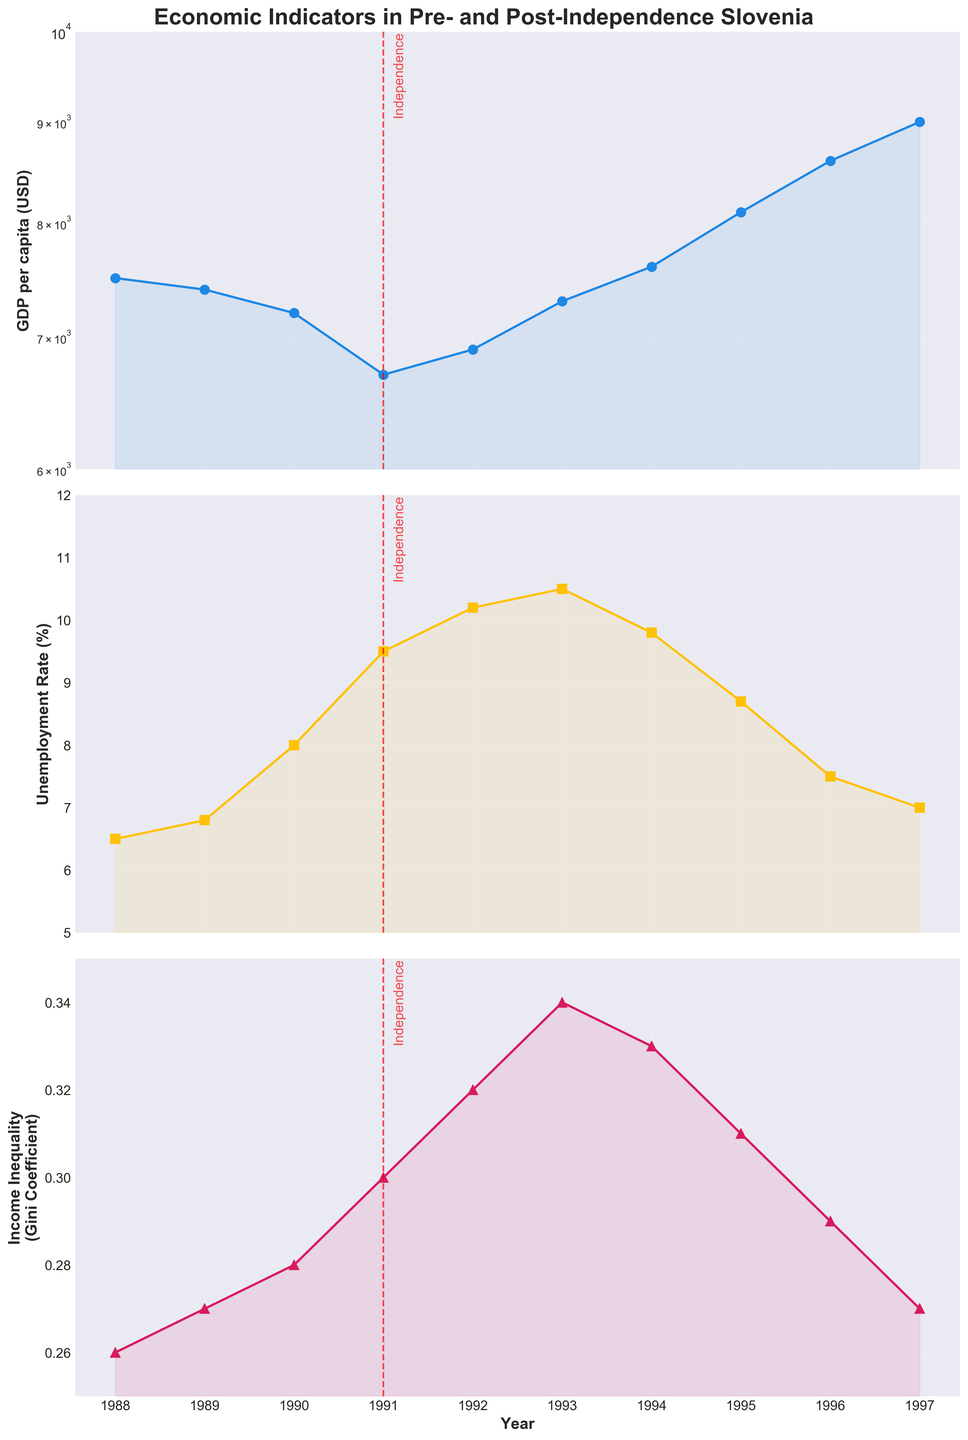How did the GDP per capita in Slovenia change from 1991 to 1997? To find out how the GDP per capita changed after independence, we look at the values in the GDP plot from 1991 to 1997. In 1991, the GDP per capita was $6700, while in 1997 it reached $9000. We note the increase in value over time.
Answer: It increased from $6700 to $9000 What was the highest unemployment rate recorded in the given years? To find the highest unemployment rate, we check the unemployment rate plot and identify the peak value. The highest rate observed is in 1993 when the unemployment rate hit 10.5%.
Answer: 10.5% in 1993 How did income inequality (Gini Coefficient) fluctuate between 1988 and 1997? To determine the fluctuations, we examine the income inequality plot. The Gini Coefficient increased from 0.26 in 1988 to a peak of 0.34 in 1993 before decreasing to 0.27 in 1997.
Answer: It increased initially, peaked in 1993, then decreased What were the GDP per capita values before and after Slovenia's independence in 1991? We need to look at the GDP per capita values directly before and after 1991: It was $7200 in 1990 and dropped to $6700 in 1991, then rose to $6900 in 1992.
Answer: $7200 in 1990 and $6700 in 1991 Which economic indicator shows the most significant change immediately after independence? To determine the most significant change, we compare the differences in GDP per capita, unemployment rate, and income inequality from 1991 to 1992. GDP per capita decreased from $6700 to $6900, unemployment rate increased from 9.5% to 10.2%, and the Gini Coefficient increased from 0.30 to 0.32. The most significant change was in GDP per capita with a noticeable decline.
Answer: GDP per capita What trend is visible in the unemployment rate from 1991 to 1997? To identify the trend, observe the values in the unemployment rate plot from 1991 to 1997. The unemployment rate increased until 1993 (reaching 10.5%) and then consistently decreased each year to 7% in 1997.
Answer: It first increased, then decreased Which year showed the lowest GDP per capita, and what was the value? To find the year with the lowest GDP per capita, we inspect the GDP plot and identify the lowest point. In 1991, the GDP per capita reached its lowest value at $6700.
Answer: 1991, $6700 How does the change in GDP per capita from 1988 to 1997 compare to the change in the unemployment rate over the same period? To compare, we calculate the change in GDP and unemployment rate from the start to the end of the period. GDP per capita increased from $7500 to $9000, a change of $1500. Unemployment rate ranged from 6.5% to 7.0%, a change of 0.5%. The GDP per capita saw a more substantial change compared to the unemployment rate.
Answer: GDP per capita increased by $1500; unemployment rate changed by 0.5% Was there a direct correlation between changes in GDP per capita and income inequality over the years? To analyze correlation, observe changes in GDP per capita and the Gini Coefficient. Initially, as GDP decreased from 1988 to 1991, income inequality increased. Post-1991, as GDP increased, inequality first rose, then declined. The trends suggest an inverse relationship initially, followed by a mixed trend post-1991.
Answer: Mixed correlation 